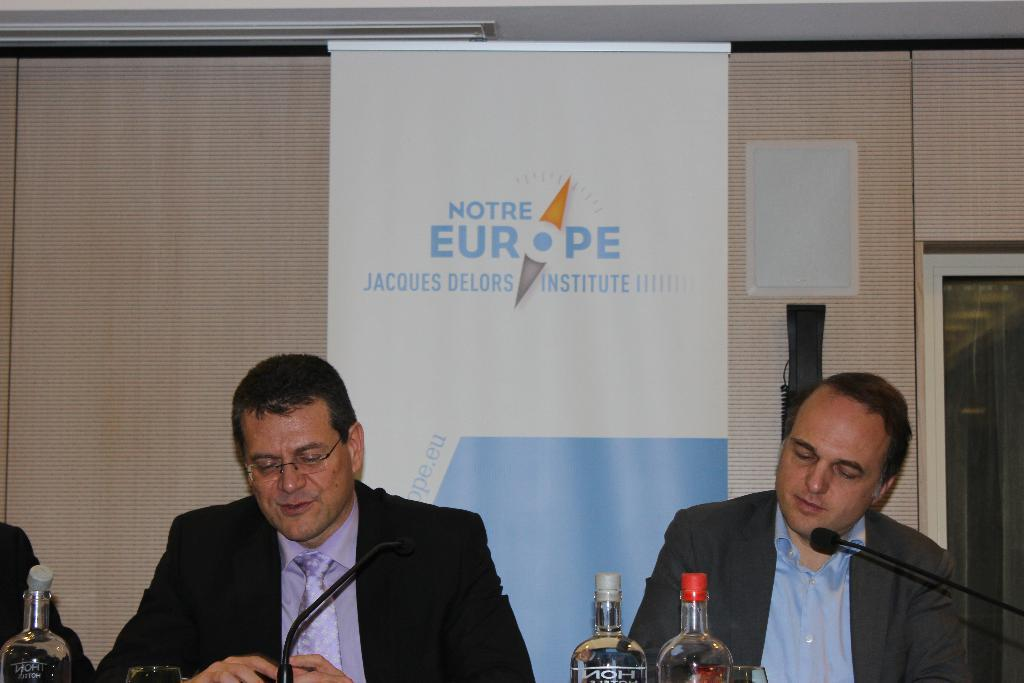<image>
Summarize the visual content of the image. men in suits in front of microphones with a notre europe banner behind them 